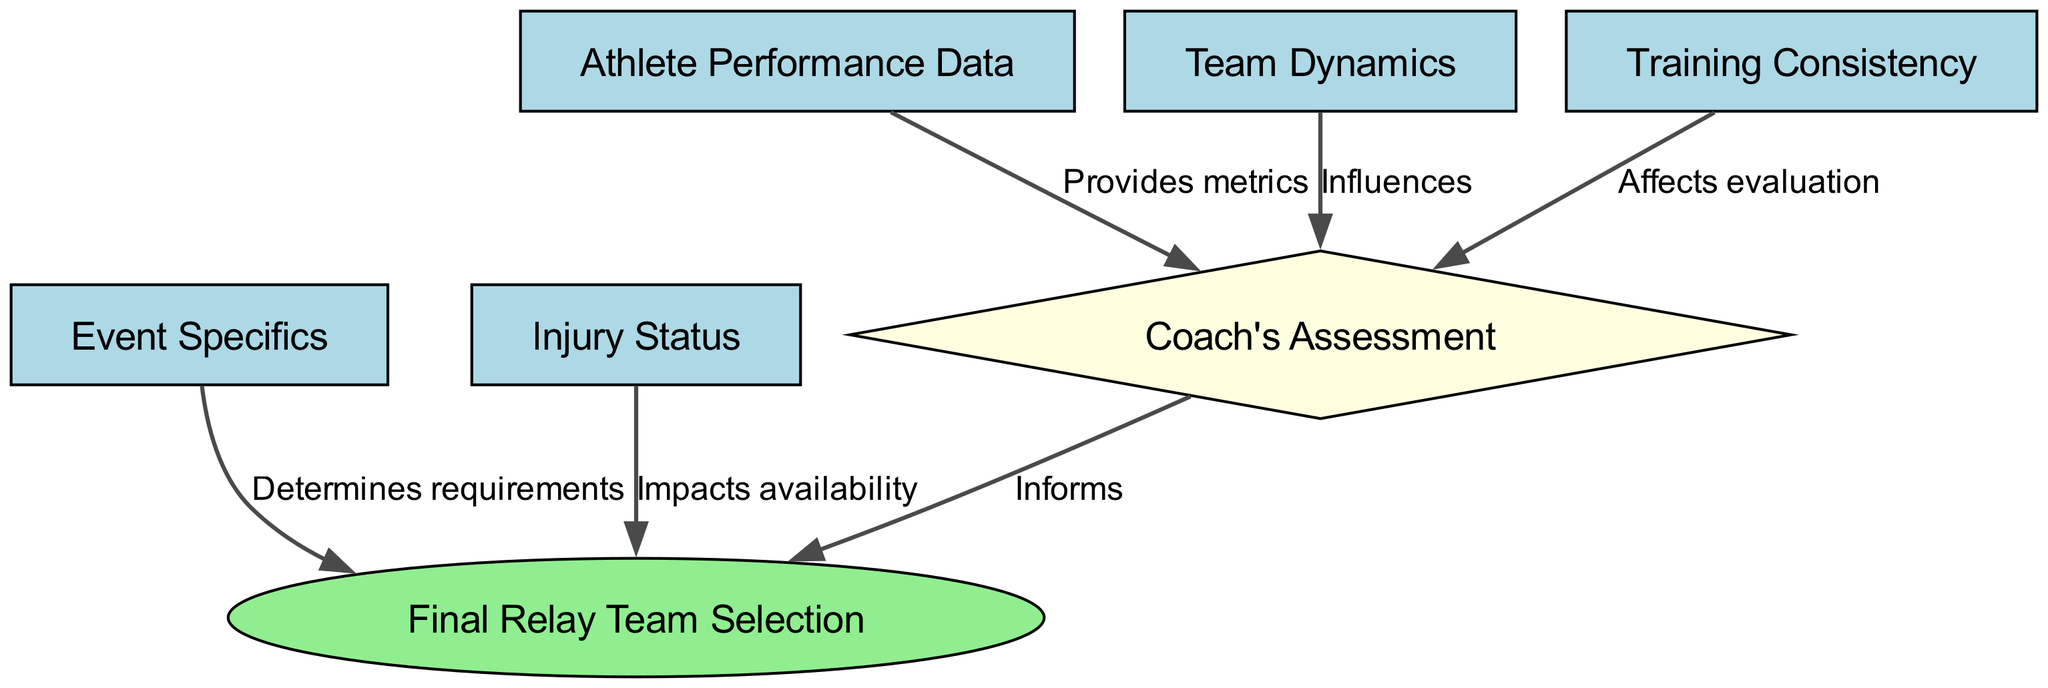What is the shape of the node representing the Coach's Assessment? The diagram indicates that the Coach's Assessment node is a diamond shape, as specified by the properties set for that particular node.
Answer: diamond How many nodes are there in the graph? By counting all the nodes listed in the data, we can determine that there are a total of 6 distinct nodes present in the diagram.
Answer: 6 Which node influences the Coach's Assessment? The edges show that Team Dynamics influence the Coach's Assessment, as indicated by the connecting edge labeled "Influences."
Answer: Team Dynamics What does the Injury Status node impact? The relationship highlighted by the edge labeled "Impacts availability" shows that the Injury Status node impacts the Final Relay Team Selection.
Answer: Final Relay Team Selection What type of edge connects Athlete Performance Data to Coach's Assessment? A directed edge labeled "Provides metrics" connects Athlete Performance Data to Coach's Assessment, demonstrating the relationship between these nodes.
Answer: Provides metrics Which node determines requirements for Final Relay Team Selection? Event Specifics is indicated by the edge labeled "Determines requirements," making it the node that defines what is necessary for the Final Relay Team Selection.
Answer: Event Specifics How many edges are there leading to the Final Relay Team Selection? By analyzing the edges directed toward the Final Relay Team Selection node, we find there are a total of 3 edges connected to it, indicating influential factors.
Answer: 3 What does Training Consistency affect? The directed edge labeled "Affects evaluation" shows that Training Consistency affects the Coach's Assessment.
Answer: Coach's Assessment Which node is a final decision point in the diagram? The Final Relay Team Selection node is identified as an ellipse, signifying that it serves as the concluding decision point in the relay team selection process.
Answer: Final Relay Team Selection 